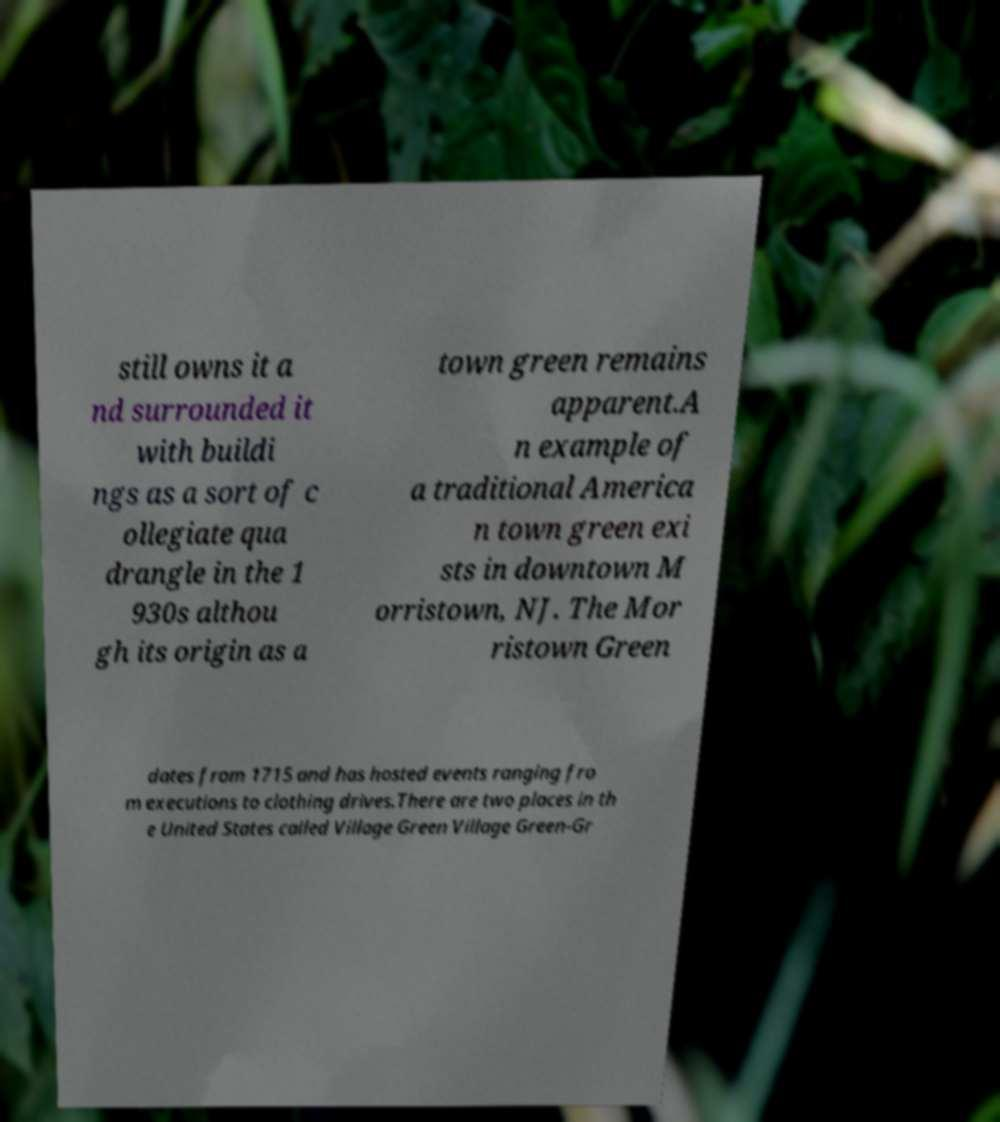Please read and relay the text visible in this image. What does it say? still owns it a nd surrounded it with buildi ngs as a sort of c ollegiate qua drangle in the 1 930s althou gh its origin as a town green remains apparent.A n example of a traditional America n town green exi sts in downtown M orristown, NJ. The Mor ristown Green dates from 1715 and has hosted events ranging fro m executions to clothing drives.There are two places in th e United States called Village Green Village Green-Gr 